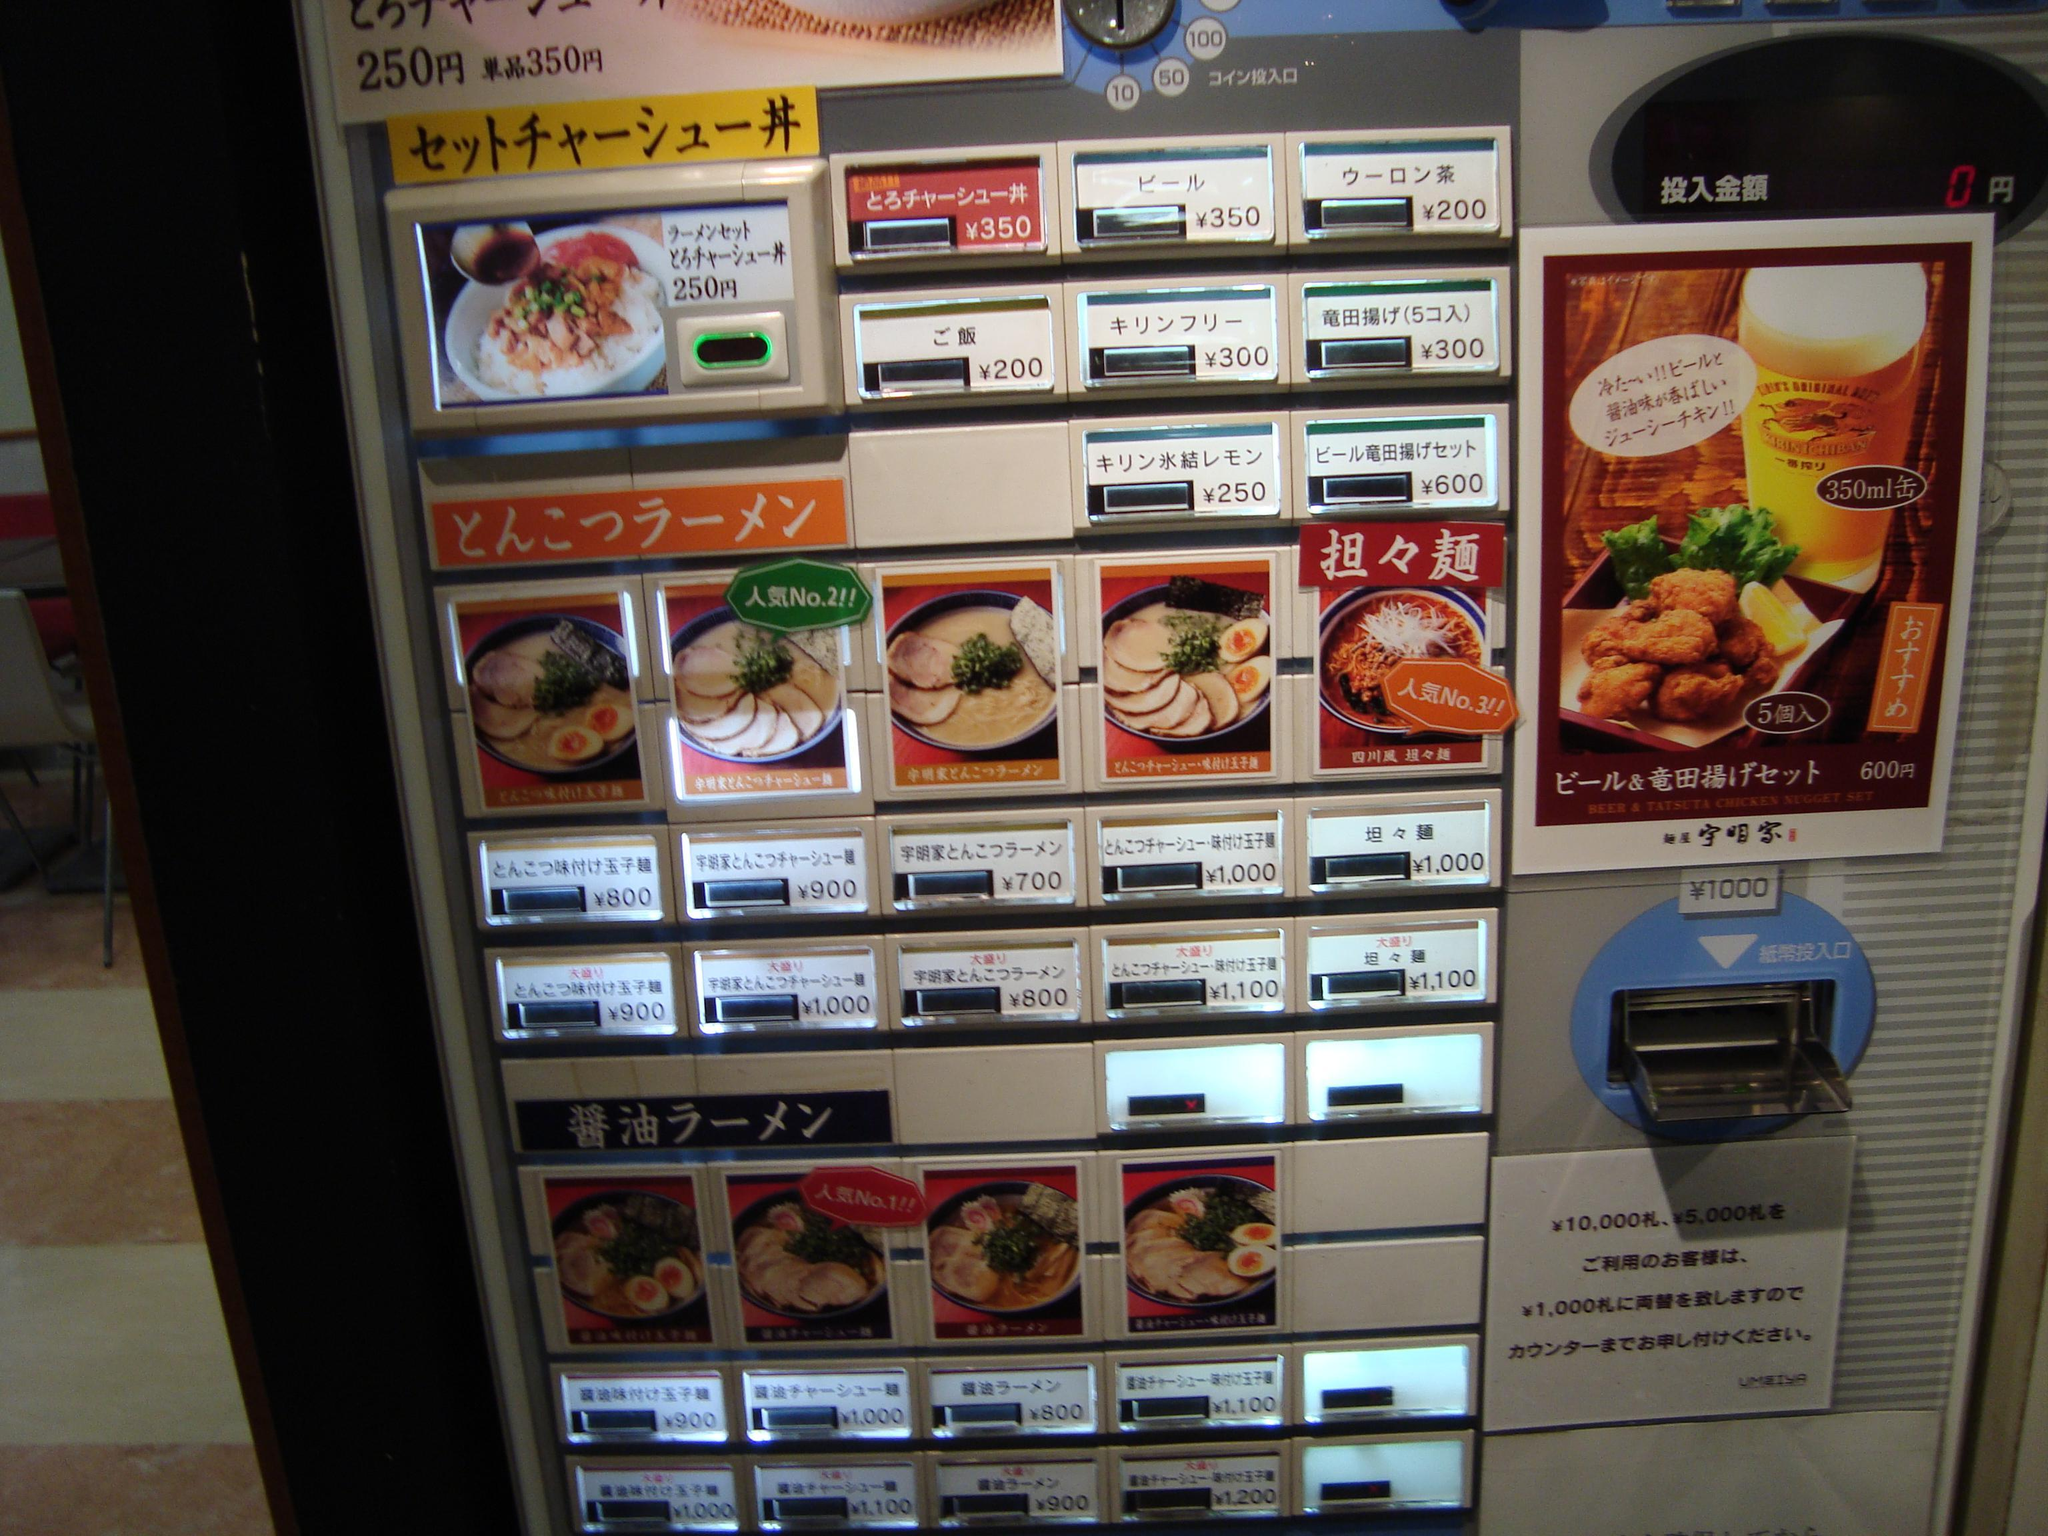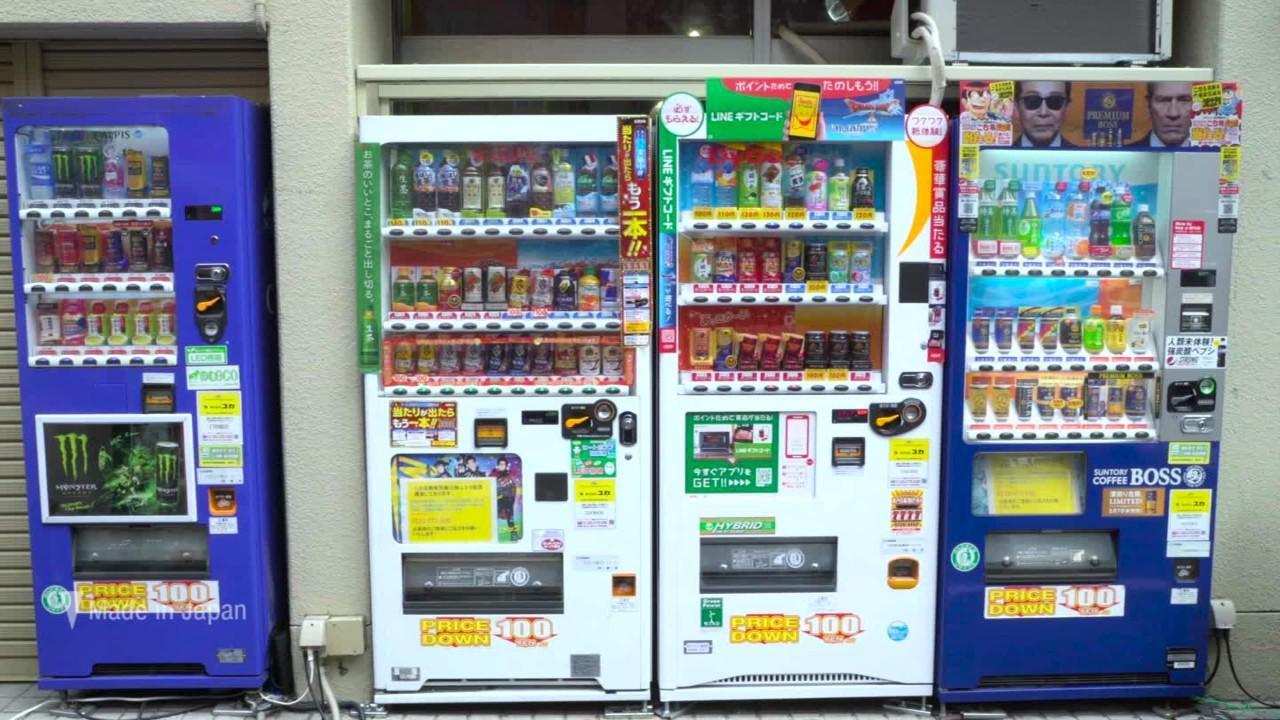The first image is the image on the left, the second image is the image on the right. For the images shown, is this caption "In a row of at least five vending machines, one machine is gray." true? Answer yes or no. No. The first image is the image on the left, the second image is the image on the right. Given the left and right images, does the statement "One of the images shows a white vending machine that offers plates of food instead of beverages." hold true? Answer yes or no. Yes. 